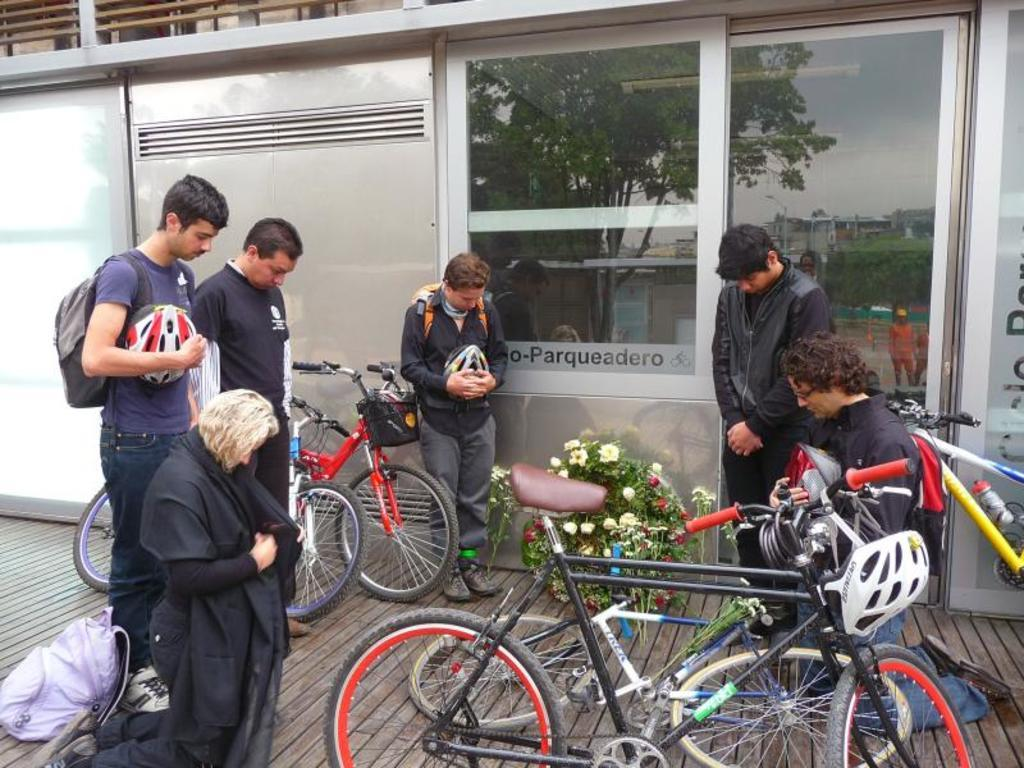How many people can be seen in the image? There are people in the image. Can you describe any specific items that the people are carrying? Two of the people are wearing backpacks. What type of vehicles are present in the image? There are bicycles in the image. Are there any safety items visible in the image? Helmets are present in the image. What type of structure is visible in the image? There are walls, a door, and windows visible in the image. Can you describe any decorative items in the image? There is a bouquet in the image. Are there any written words visible in the image? There is text on a window in the image. What is the taste of the kitten in the image? There is no kitten present in the image, so it is not possible to determine its taste. How is the yoke being used in the image? There is no yoke present in the image, so it is not possible to determine how it might be used. 